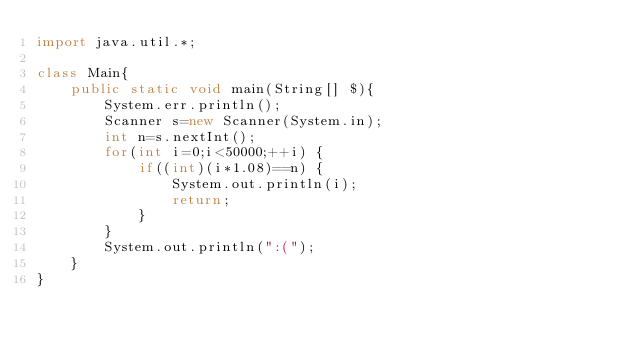Convert code to text. <code><loc_0><loc_0><loc_500><loc_500><_Java_>import java.util.*;

class Main{
	public static void main(String[] $){
		System.err.println();
		Scanner s=new Scanner(System.in);
		int n=s.nextInt();
		for(int i=0;i<50000;++i) {
			if((int)(i*1.08)==n) {
				System.out.println(i);
				return;
			}
		}
		System.out.println(":(");
	}
}
</code> 